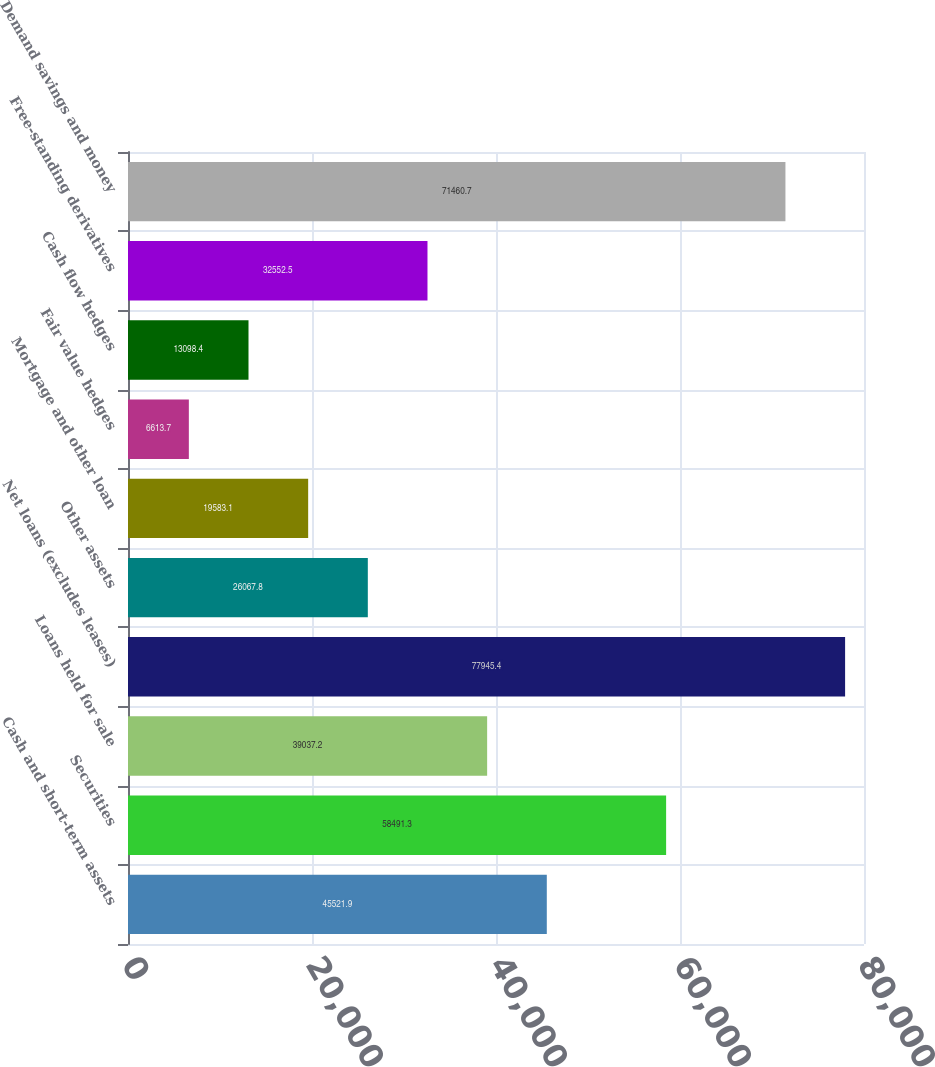Convert chart. <chart><loc_0><loc_0><loc_500><loc_500><bar_chart><fcel>Cash and short-term assets<fcel>Securities<fcel>Loans held for sale<fcel>Net loans (excludes leases)<fcel>Other assets<fcel>Mortgage and other loan<fcel>Fair value hedges<fcel>Cash flow hedges<fcel>Free-standing derivatives<fcel>Demand savings and money<nl><fcel>45521.9<fcel>58491.3<fcel>39037.2<fcel>77945.4<fcel>26067.8<fcel>19583.1<fcel>6613.7<fcel>13098.4<fcel>32552.5<fcel>71460.7<nl></chart> 